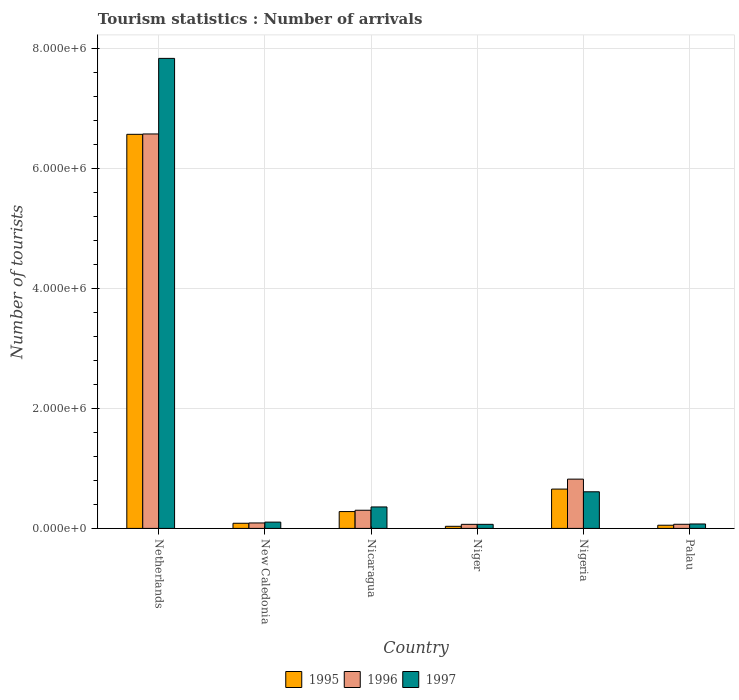How many different coloured bars are there?
Ensure brevity in your answer.  3. Are the number of bars per tick equal to the number of legend labels?
Your answer should be compact. Yes. Are the number of bars on each tick of the X-axis equal?
Provide a succinct answer. Yes. How many bars are there on the 5th tick from the left?
Make the answer very short. 3. What is the label of the 2nd group of bars from the left?
Your response must be concise. New Caledonia. In how many cases, is the number of bars for a given country not equal to the number of legend labels?
Offer a terse response. 0. What is the number of tourist arrivals in 1997 in Nicaragua?
Your answer should be compact. 3.58e+05. Across all countries, what is the maximum number of tourist arrivals in 1996?
Your answer should be compact. 6.58e+06. Across all countries, what is the minimum number of tourist arrivals in 1997?
Ensure brevity in your answer.  6.80e+04. In which country was the number of tourist arrivals in 1995 minimum?
Ensure brevity in your answer.  Niger. What is the total number of tourist arrivals in 1997 in the graph?
Make the answer very short. 9.06e+06. What is the difference between the number of tourist arrivals in 1995 in Niger and that in Nigeria?
Provide a short and direct response. -6.21e+05. What is the difference between the number of tourist arrivals in 1997 in Nigeria and the number of tourist arrivals in 1996 in Niger?
Offer a very short reply. 5.43e+05. What is the average number of tourist arrivals in 1995 per country?
Keep it short and to the point. 1.28e+06. What is the difference between the number of tourist arrivals of/in 1996 and number of tourist arrivals of/in 1995 in New Caledonia?
Ensure brevity in your answer.  5000. What is the ratio of the number of tourist arrivals in 1996 in Netherlands to that in Nigeria?
Provide a short and direct response. 8. Is the difference between the number of tourist arrivals in 1996 in New Caledonia and Nigeria greater than the difference between the number of tourist arrivals in 1995 in New Caledonia and Nigeria?
Your answer should be compact. No. What is the difference between the highest and the second highest number of tourist arrivals in 1996?
Give a very brief answer. 5.76e+06. What is the difference between the highest and the lowest number of tourist arrivals in 1997?
Give a very brief answer. 7.77e+06. In how many countries, is the number of tourist arrivals in 1996 greater than the average number of tourist arrivals in 1996 taken over all countries?
Ensure brevity in your answer.  1. What does the 2nd bar from the left in Nigeria represents?
Keep it short and to the point. 1996. Is it the case that in every country, the sum of the number of tourist arrivals in 1995 and number of tourist arrivals in 1997 is greater than the number of tourist arrivals in 1996?
Ensure brevity in your answer.  Yes. Are all the bars in the graph horizontal?
Make the answer very short. No. How many countries are there in the graph?
Ensure brevity in your answer.  6. What is the difference between two consecutive major ticks on the Y-axis?
Give a very brief answer. 2.00e+06. Are the values on the major ticks of Y-axis written in scientific E-notation?
Your answer should be very brief. Yes. Where does the legend appear in the graph?
Ensure brevity in your answer.  Bottom center. How are the legend labels stacked?
Your response must be concise. Horizontal. What is the title of the graph?
Offer a very short reply. Tourism statistics : Number of arrivals. Does "1995" appear as one of the legend labels in the graph?
Offer a terse response. Yes. What is the label or title of the Y-axis?
Give a very brief answer. Number of tourists. What is the Number of tourists in 1995 in Netherlands?
Your answer should be very brief. 6.57e+06. What is the Number of tourists of 1996 in Netherlands?
Offer a very short reply. 6.58e+06. What is the Number of tourists in 1997 in Netherlands?
Keep it short and to the point. 7.84e+06. What is the Number of tourists of 1995 in New Caledonia?
Ensure brevity in your answer.  8.60e+04. What is the Number of tourists of 1996 in New Caledonia?
Offer a very short reply. 9.10e+04. What is the Number of tourists in 1997 in New Caledonia?
Give a very brief answer. 1.05e+05. What is the Number of tourists of 1995 in Nicaragua?
Your response must be concise. 2.81e+05. What is the Number of tourists of 1996 in Nicaragua?
Provide a succinct answer. 3.03e+05. What is the Number of tourists of 1997 in Nicaragua?
Offer a terse response. 3.58e+05. What is the Number of tourists of 1995 in Niger?
Offer a very short reply. 3.50e+04. What is the Number of tourists in 1996 in Niger?
Keep it short and to the point. 6.80e+04. What is the Number of tourists in 1997 in Niger?
Your answer should be very brief. 6.80e+04. What is the Number of tourists in 1995 in Nigeria?
Make the answer very short. 6.56e+05. What is the Number of tourists of 1996 in Nigeria?
Offer a terse response. 8.22e+05. What is the Number of tourists of 1997 in Nigeria?
Your answer should be compact. 6.11e+05. What is the Number of tourists of 1995 in Palau?
Your answer should be very brief. 5.30e+04. What is the Number of tourists in 1996 in Palau?
Your response must be concise. 6.90e+04. What is the Number of tourists of 1997 in Palau?
Keep it short and to the point. 7.40e+04. Across all countries, what is the maximum Number of tourists of 1995?
Offer a very short reply. 6.57e+06. Across all countries, what is the maximum Number of tourists in 1996?
Your answer should be very brief. 6.58e+06. Across all countries, what is the maximum Number of tourists of 1997?
Offer a very short reply. 7.84e+06. Across all countries, what is the minimum Number of tourists of 1995?
Your answer should be compact. 3.50e+04. Across all countries, what is the minimum Number of tourists in 1996?
Offer a very short reply. 6.80e+04. Across all countries, what is the minimum Number of tourists of 1997?
Offer a very short reply. 6.80e+04. What is the total Number of tourists of 1995 in the graph?
Give a very brief answer. 7.68e+06. What is the total Number of tourists of 1996 in the graph?
Provide a succinct answer. 7.93e+06. What is the total Number of tourists in 1997 in the graph?
Ensure brevity in your answer.  9.06e+06. What is the difference between the Number of tourists of 1995 in Netherlands and that in New Caledonia?
Your response must be concise. 6.49e+06. What is the difference between the Number of tourists in 1996 in Netherlands and that in New Caledonia?
Provide a short and direct response. 6.49e+06. What is the difference between the Number of tourists in 1997 in Netherlands and that in New Caledonia?
Make the answer very short. 7.74e+06. What is the difference between the Number of tourists of 1995 in Netherlands and that in Nicaragua?
Your answer should be very brief. 6.29e+06. What is the difference between the Number of tourists in 1996 in Netherlands and that in Nicaragua?
Offer a very short reply. 6.28e+06. What is the difference between the Number of tourists in 1997 in Netherlands and that in Nicaragua?
Ensure brevity in your answer.  7.48e+06. What is the difference between the Number of tourists in 1995 in Netherlands and that in Niger?
Make the answer very short. 6.54e+06. What is the difference between the Number of tourists in 1996 in Netherlands and that in Niger?
Your answer should be compact. 6.51e+06. What is the difference between the Number of tourists in 1997 in Netherlands and that in Niger?
Keep it short and to the point. 7.77e+06. What is the difference between the Number of tourists of 1995 in Netherlands and that in Nigeria?
Make the answer very short. 5.92e+06. What is the difference between the Number of tourists of 1996 in Netherlands and that in Nigeria?
Your answer should be compact. 5.76e+06. What is the difference between the Number of tourists in 1997 in Netherlands and that in Nigeria?
Make the answer very short. 7.23e+06. What is the difference between the Number of tourists in 1995 in Netherlands and that in Palau?
Make the answer very short. 6.52e+06. What is the difference between the Number of tourists of 1996 in Netherlands and that in Palau?
Ensure brevity in your answer.  6.51e+06. What is the difference between the Number of tourists in 1997 in Netherlands and that in Palau?
Ensure brevity in your answer.  7.77e+06. What is the difference between the Number of tourists of 1995 in New Caledonia and that in Nicaragua?
Your answer should be compact. -1.95e+05. What is the difference between the Number of tourists of 1996 in New Caledonia and that in Nicaragua?
Make the answer very short. -2.12e+05. What is the difference between the Number of tourists of 1997 in New Caledonia and that in Nicaragua?
Keep it short and to the point. -2.53e+05. What is the difference between the Number of tourists of 1995 in New Caledonia and that in Niger?
Make the answer very short. 5.10e+04. What is the difference between the Number of tourists in 1996 in New Caledonia and that in Niger?
Offer a very short reply. 2.30e+04. What is the difference between the Number of tourists of 1997 in New Caledonia and that in Niger?
Provide a short and direct response. 3.70e+04. What is the difference between the Number of tourists of 1995 in New Caledonia and that in Nigeria?
Make the answer very short. -5.70e+05. What is the difference between the Number of tourists in 1996 in New Caledonia and that in Nigeria?
Give a very brief answer. -7.31e+05. What is the difference between the Number of tourists of 1997 in New Caledonia and that in Nigeria?
Your answer should be very brief. -5.06e+05. What is the difference between the Number of tourists in 1995 in New Caledonia and that in Palau?
Provide a short and direct response. 3.30e+04. What is the difference between the Number of tourists in 1996 in New Caledonia and that in Palau?
Provide a succinct answer. 2.20e+04. What is the difference between the Number of tourists of 1997 in New Caledonia and that in Palau?
Ensure brevity in your answer.  3.10e+04. What is the difference between the Number of tourists in 1995 in Nicaragua and that in Niger?
Your answer should be compact. 2.46e+05. What is the difference between the Number of tourists of 1996 in Nicaragua and that in Niger?
Provide a succinct answer. 2.35e+05. What is the difference between the Number of tourists of 1995 in Nicaragua and that in Nigeria?
Your answer should be compact. -3.75e+05. What is the difference between the Number of tourists in 1996 in Nicaragua and that in Nigeria?
Provide a short and direct response. -5.19e+05. What is the difference between the Number of tourists in 1997 in Nicaragua and that in Nigeria?
Offer a terse response. -2.53e+05. What is the difference between the Number of tourists in 1995 in Nicaragua and that in Palau?
Ensure brevity in your answer.  2.28e+05. What is the difference between the Number of tourists of 1996 in Nicaragua and that in Palau?
Keep it short and to the point. 2.34e+05. What is the difference between the Number of tourists of 1997 in Nicaragua and that in Palau?
Provide a short and direct response. 2.84e+05. What is the difference between the Number of tourists in 1995 in Niger and that in Nigeria?
Your answer should be compact. -6.21e+05. What is the difference between the Number of tourists in 1996 in Niger and that in Nigeria?
Your answer should be very brief. -7.54e+05. What is the difference between the Number of tourists in 1997 in Niger and that in Nigeria?
Your answer should be compact. -5.43e+05. What is the difference between the Number of tourists in 1995 in Niger and that in Palau?
Offer a very short reply. -1.80e+04. What is the difference between the Number of tourists of 1996 in Niger and that in Palau?
Keep it short and to the point. -1000. What is the difference between the Number of tourists of 1997 in Niger and that in Palau?
Offer a very short reply. -6000. What is the difference between the Number of tourists of 1995 in Nigeria and that in Palau?
Offer a terse response. 6.03e+05. What is the difference between the Number of tourists of 1996 in Nigeria and that in Palau?
Ensure brevity in your answer.  7.53e+05. What is the difference between the Number of tourists of 1997 in Nigeria and that in Palau?
Make the answer very short. 5.37e+05. What is the difference between the Number of tourists of 1995 in Netherlands and the Number of tourists of 1996 in New Caledonia?
Ensure brevity in your answer.  6.48e+06. What is the difference between the Number of tourists in 1995 in Netherlands and the Number of tourists in 1997 in New Caledonia?
Offer a terse response. 6.47e+06. What is the difference between the Number of tourists of 1996 in Netherlands and the Number of tourists of 1997 in New Caledonia?
Ensure brevity in your answer.  6.48e+06. What is the difference between the Number of tourists in 1995 in Netherlands and the Number of tourists in 1996 in Nicaragua?
Make the answer very short. 6.27e+06. What is the difference between the Number of tourists in 1995 in Netherlands and the Number of tourists in 1997 in Nicaragua?
Offer a very short reply. 6.22e+06. What is the difference between the Number of tourists of 1996 in Netherlands and the Number of tourists of 1997 in Nicaragua?
Offer a very short reply. 6.22e+06. What is the difference between the Number of tourists of 1995 in Netherlands and the Number of tourists of 1996 in Niger?
Your answer should be very brief. 6.51e+06. What is the difference between the Number of tourists in 1995 in Netherlands and the Number of tourists in 1997 in Niger?
Offer a terse response. 6.51e+06. What is the difference between the Number of tourists in 1996 in Netherlands and the Number of tourists in 1997 in Niger?
Your answer should be compact. 6.51e+06. What is the difference between the Number of tourists in 1995 in Netherlands and the Number of tourists in 1996 in Nigeria?
Provide a short and direct response. 5.75e+06. What is the difference between the Number of tourists in 1995 in Netherlands and the Number of tourists in 1997 in Nigeria?
Provide a short and direct response. 5.96e+06. What is the difference between the Number of tourists in 1996 in Netherlands and the Number of tourists in 1997 in Nigeria?
Your response must be concise. 5.97e+06. What is the difference between the Number of tourists in 1995 in Netherlands and the Number of tourists in 1996 in Palau?
Offer a very short reply. 6.50e+06. What is the difference between the Number of tourists of 1995 in Netherlands and the Number of tourists of 1997 in Palau?
Your answer should be compact. 6.50e+06. What is the difference between the Number of tourists of 1996 in Netherlands and the Number of tourists of 1997 in Palau?
Give a very brief answer. 6.51e+06. What is the difference between the Number of tourists of 1995 in New Caledonia and the Number of tourists of 1996 in Nicaragua?
Your response must be concise. -2.17e+05. What is the difference between the Number of tourists of 1995 in New Caledonia and the Number of tourists of 1997 in Nicaragua?
Offer a very short reply. -2.72e+05. What is the difference between the Number of tourists of 1996 in New Caledonia and the Number of tourists of 1997 in Nicaragua?
Your answer should be very brief. -2.67e+05. What is the difference between the Number of tourists in 1995 in New Caledonia and the Number of tourists in 1996 in Niger?
Your answer should be very brief. 1.80e+04. What is the difference between the Number of tourists in 1995 in New Caledonia and the Number of tourists in 1997 in Niger?
Your answer should be compact. 1.80e+04. What is the difference between the Number of tourists in 1996 in New Caledonia and the Number of tourists in 1997 in Niger?
Make the answer very short. 2.30e+04. What is the difference between the Number of tourists of 1995 in New Caledonia and the Number of tourists of 1996 in Nigeria?
Your response must be concise. -7.36e+05. What is the difference between the Number of tourists in 1995 in New Caledonia and the Number of tourists in 1997 in Nigeria?
Give a very brief answer. -5.25e+05. What is the difference between the Number of tourists of 1996 in New Caledonia and the Number of tourists of 1997 in Nigeria?
Your answer should be compact. -5.20e+05. What is the difference between the Number of tourists of 1995 in New Caledonia and the Number of tourists of 1996 in Palau?
Provide a succinct answer. 1.70e+04. What is the difference between the Number of tourists in 1995 in New Caledonia and the Number of tourists in 1997 in Palau?
Your answer should be compact. 1.20e+04. What is the difference between the Number of tourists of 1996 in New Caledonia and the Number of tourists of 1997 in Palau?
Your answer should be very brief. 1.70e+04. What is the difference between the Number of tourists of 1995 in Nicaragua and the Number of tourists of 1996 in Niger?
Make the answer very short. 2.13e+05. What is the difference between the Number of tourists of 1995 in Nicaragua and the Number of tourists of 1997 in Niger?
Your answer should be very brief. 2.13e+05. What is the difference between the Number of tourists of 1996 in Nicaragua and the Number of tourists of 1997 in Niger?
Ensure brevity in your answer.  2.35e+05. What is the difference between the Number of tourists of 1995 in Nicaragua and the Number of tourists of 1996 in Nigeria?
Your answer should be compact. -5.41e+05. What is the difference between the Number of tourists in 1995 in Nicaragua and the Number of tourists in 1997 in Nigeria?
Provide a succinct answer. -3.30e+05. What is the difference between the Number of tourists in 1996 in Nicaragua and the Number of tourists in 1997 in Nigeria?
Keep it short and to the point. -3.08e+05. What is the difference between the Number of tourists of 1995 in Nicaragua and the Number of tourists of 1996 in Palau?
Your answer should be compact. 2.12e+05. What is the difference between the Number of tourists in 1995 in Nicaragua and the Number of tourists in 1997 in Palau?
Keep it short and to the point. 2.07e+05. What is the difference between the Number of tourists in 1996 in Nicaragua and the Number of tourists in 1997 in Palau?
Offer a terse response. 2.29e+05. What is the difference between the Number of tourists in 1995 in Niger and the Number of tourists in 1996 in Nigeria?
Provide a succinct answer. -7.87e+05. What is the difference between the Number of tourists of 1995 in Niger and the Number of tourists of 1997 in Nigeria?
Keep it short and to the point. -5.76e+05. What is the difference between the Number of tourists in 1996 in Niger and the Number of tourists in 1997 in Nigeria?
Make the answer very short. -5.43e+05. What is the difference between the Number of tourists of 1995 in Niger and the Number of tourists of 1996 in Palau?
Offer a very short reply. -3.40e+04. What is the difference between the Number of tourists in 1995 in Niger and the Number of tourists in 1997 in Palau?
Your answer should be very brief. -3.90e+04. What is the difference between the Number of tourists in 1996 in Niger and the Number of tourists in 1997 in Palau?
Offer a terse response. -6000. What is the difference between the Number of tourists of 1995 in Nigeria and the Number of tourists of 1996 in Palau?
Keep it short and to the point. 5.87e+05. What is the difference between the Number of tourists in 1995 in Nigeria and the Number of tourists in 1997 in Palau?
Your answer should be compact. 5.82e+05. What is the difference between the Number of tourists of 1996 in Nigeria and the Number of tourists of 1997 in Palau?
Your response must be concise. 7.48e+05. What is the average Number of tourists of 1995 per country?
Make the answer very short. 1.28e+06. What is the average Number of tourists of 1996 per country?
Give a very brief answer. 1.32e+06. What is the average Number of tourists of 1997 per country?
Your answer should be compact. 1.51e+06. What is the difference between the Number of tourists in 1995 and Number of tourists in 1996 in Netherlands?
Your answer should be compact. -6000. What is the difference between the Number of tourists of 1995 and Number of tourists of 1997 in Netherlands?
Offer a terse response. -1.27e+06. What is the difference between the Number of tourists of 1996 and Number of tourists of 1997 in Netherlands?
Offer a terse response. -1.26e+06. What is the difference between the Number of tourists in 1995 and Number of tourists in 1996 in New Caledonia?
Offer a terse response. -5000. What is the difference between the Number of tourists in 1995 and Number of tourists in 1997 in New Caledonia?
Give a very brief answer. -1.90e+04. What is the difference between the Number of tourists of 1996 and Number of tourists of 1997 in New Caledonia?
Your answer should be compact. -1.40e+04. What is the difference between the Number of tourists of 1995 and Number of tourists of 1996 in Nicaragua?
Provide a succinct answer. -2.20e+04. What is the difference between the Number of tourists of 1995 and Number of tourists of 1997 in Nicaragua?
Keep it short and to the point. -7.70e+04. What is the difference between the Number of tourists of 1996 and Number of tourists of 1997 in Nicaragua?
Keep it short and to the point. -5.50e+04. What is the difference between the Number of tourists in 1995 and Number of tourists in 1996 in Niger?
Your response must be concise. -3.30e+04. What is the difference between the Number of tourists in 1995 and Number of tourists in 1997 in Niger?
Ensure brevity in your answer.  -3.30e+04. What is the difference between the Number of tourists of 1996 and Number of tourists of 1997 in Niger?
Ensure brevity in your answer.  0. What is the difference between the Number of tourists in 1995 and Number of tourists in 1996 in Nigeria?
Your answer should be compact. -1.66e+05. What is the difference between the Number of tourists in 1995 and Number of tourists in 1997 in Nigeria?
Offer a terse response. 4.50e+04. What is the difference between the Number of tourists of 1996 and Number of tourists of 1997 in Nigeria?
Provide a short and direct response. 2.11e+05. What is the difference between the Number of tourists in 1995 and Number of tourists in 1996 in Palau?
Your answer should be compact. -1.60e+04. What is the difference between the Number of tourists in 1995 and Number of tourists in 1997 in Palau?
Make the answer very short. -2.10e+04. What is the difference between the Number of tourists in 1996 and Number of tourists in 1997 in Palau?
Ensure brevity in your answer.  -5000. What is the ratio of the Number of tourists of 1995 in Netherlands to that in New Caledonia?
Provide a succinct answer. 76.44. What is the ratio of the Number of tourists in 1996 in Netherlands to that in New Caledonia?
Your answer should be compact. 72.31. What is the ratio of the Number of tourists of 1997 in Netherlands to that in New Caledonia?
Make the answer very short. 74.68. What is the ratio of the Number of tourists in 1995 in Netherlands to that in Nicaragua?
Provide a succinct answer. 23.39. What is the ratio of the Number of tourists of 1996 in Netherlands to that in Nicaragua?
Your response must be concise. 21.72. What is the ratio of the Number of tourists of 1997 in Netherlands to that in Nicaragua?
Your answer should be very brief. 21.9. What is the ratio of the Number of tourists in 1995 in Netherlands to that in Niger?
Your answer should be compact. 187.83. What is the ratio of the Number of tourists in 1996 in Netherlands to that in Niger?
Provide a short and direct response. 96.76. What is the ratio of the Number of tourists in 1997 in Netherlands to that in Niger?
Your response must be concise. 115.31. What is the ratio of the Number of tourists of 1995 in Netherlands to that in Nigeria?
Ensure brevity in your answer.  10.02. What is the ratio of the Number of tourists in 1996 in Netherlands to that in Nigeria?
Your answer should be compact. 8. What is the ratio of the Number of tourists of 1997 in Netherlands to that in Nigeria?
Your answer should be very brief. 12.83. What is the ratio of the Number of tourists of 1995 in Netherlands to that in Palau?
Offer a very short reply. 124.04. What is the ratio of the Number of tourists in 1996 in Netherlands to that in Palau?
Your answer should be compact. 95.36. What is the ratio of the Number of tourists of 1997 in Netherlands to that in Palau?
Offer a very short reply. 105.96. What is the ratio of the Number of tourists of 1995 in New Caledonia to that in Nicaragua?
Your answer should be compact. 0.31. What is the ratio of the Number of tourists of 1996 in New Caledonia to that in Nicaragua?
Ensure brevity in your answer.  0.3. What is the ratio of the Number of tourists of 1997 in New Caledonia to that in Nicaragua?
Your response must be concise. 0.29. What is the ratio of the Number of tourists in 1995 in New Caledonia to that in Niger?
Your response must be concise. 2.46. What is the ratio of the Number of tourists in 1996 in New Caledonia to that in Niger?
Offer a very short reply. 1.34. What is the ratio of the Number of tourists of 1997 in New Caledonia to that in Niger?
Your answer should be very brief. 1.54. What is the ratio of the Number of tourists in 1995 in New Caledonia to that in Nigeria?
Give a very brief answer. 0.13. What is the ratio of the Number of tourists of 1996 in New Caledonia to that in Nigeria?
Your answer should be very brief. 0.11. What is the ratio of the Number of tourists in 1997 in New Caledonia to that in Nigeria?
Ensure brevity in your answer.  0.17. What is the ratio of the Number of tourists of 1995 in New Caledonia to that in Palau?
Your answer should be compact. 1.62. What is the ratio of the Number of tourists of 1996 in New Caledonia to that in Palau?
Your response must be concise. 1.32. What is the ratio of the Number of tourists of 1997 in New Caledonia to that in Palau?
Provide a succinct answer. 1.42. What is the ratio of the Number of tourists in 1995 in Nicaragua to that in Niger?
Keep it short and to the point. 8.03. What is the ratio of the Number of tourists of 1996 in Nicaragua to that in Niger?
Provide a short and direct response. 4.46. What is the ratio of the Number of tourists of 1997 in Nicaragua to that in Niger?
Provide a short and direct response. 5.26. What is the ratio of the Number of tourists of 1995 in Nicaragua to that in Nigeria?
Your response must be concise. 0.43. What is the ratio of the Number of tourists in 1996 in Nicaragua to that in Nigeria?
Make the answer very short. 0.37. What is the ratio of the Number of tourists in 1997 in Nicaragua to that in Nigeria?
Offer a very short reply. 0.59. What is the ratio of the Number of tourists of 1995 in Nicaragua to that in Palau?
Give a very brief answer. 5.3. What is the ratio of the Number of tourists in 1996 in Nicaragua to that in Palau?
Ensure brevity in your answer.  4.39. What is the ratio of the Number of tourists of 1997 in Nicaragua to that in Palau?
Your answer should be compact. 4.84. What is the ratio of the Number of tourists in 1995 in Niger to that in Nigeria?
Provide a short and direct response. 0.05. What is the ratio of the Number of tourists in 1996 in Niger to that in Nigeria?
Your answer should be compact. 0.08. What is the ratio of the Number of tourists of 1997 in Niger to that in Nigeria?
Your answer should be compact. 0.11. What is the ratio of the Number of tourists in 1995 in Niger to that in Palau?
Provide a short and direct response. 0.66. What is the ratio of the Number of tourists of 1996 in Niger to that in Palau?
Make the answer very short. 0.99. What is the ratio of the Number of tourists in 1997 in Niger to that in Palau?
Provide a succinct answer. 0.92. What is the ratio of the Number of tourists in 1995 in Nigeria to that in Palau?
Keep it short and to the point. 12.38. What is the ratio of the Number of tourists in 1996 in Nigeria to that in Palau?
Your response must be concise. 11.91. What is the ratio of the Number of tourists in 1997 in Nigeria to that in Palau?
Your answer should be compact. 8.26. What is the difference between the highest and the second highest Number of tourists in 1995?
Your answer should be very brief. 5.92e+06. What is the difference between the highest and the second highest Number of tourists in 1996?
Make the answer very short. 5.76e+06. What is the difference between the highest and the second highest Number of tourists in 1997?
Offer a terse response. 7.23e+06. What is the difference between the highest and the lowest Number of tourists of 1995?
Ensure brevity in your answer.  6.54e+06. What is the difference between the highest and the lowest Number of tourists of 1996?
Ensure brevity in your answer.  6.51e+06. What is the difference between the highest and the lowest Number of tourists of 1997?
Provide a short and direct response. 7.77e+06. 